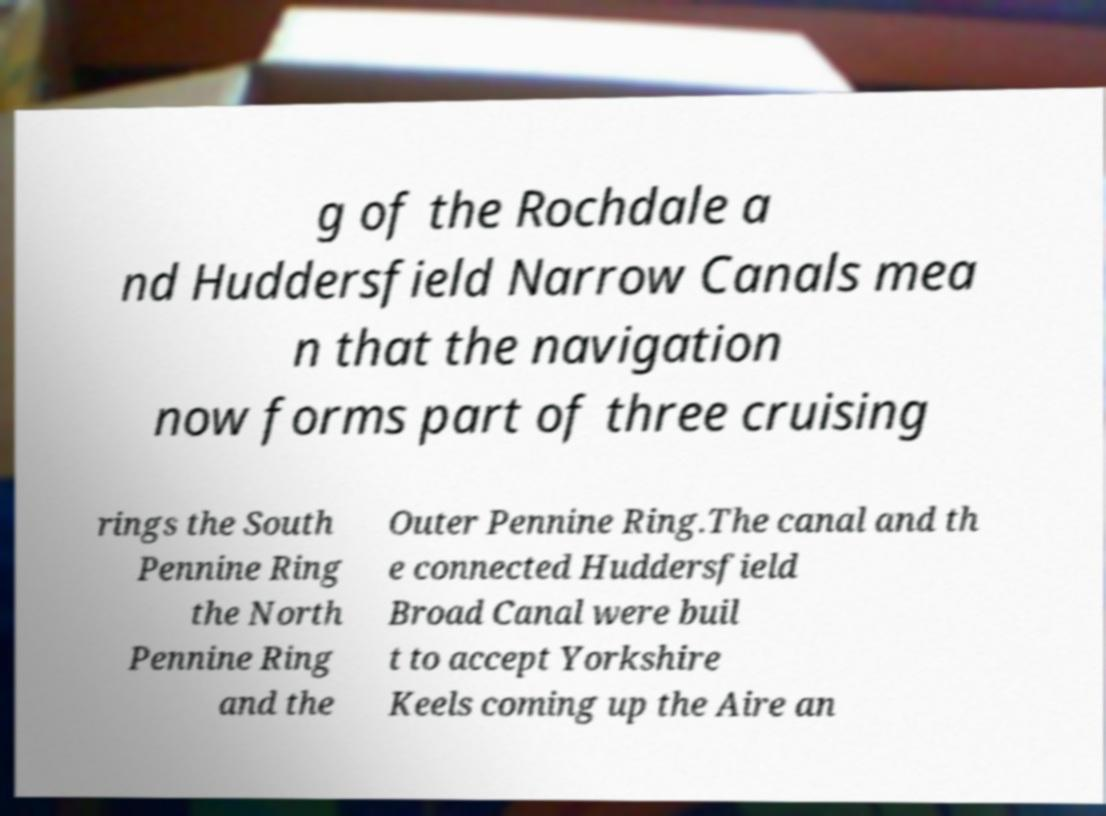Please read and relay the text visible in this image. What does it say? g of the Rochdale a nd Huddersfield Narrow Canals mea n that the navigation now forms part of three cruising rings the South Pennine Ring the North Pennine Ring and the Outer Pennine Ring.The canal and th e connected Huddersfield Broad Canal were buil t to accept Yorkshire Keels coming up the Aire an 